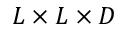Convert formula to latex. <formula><loc_0><loc_0><loc_500><loc_500>L \times L \times D</formula> 